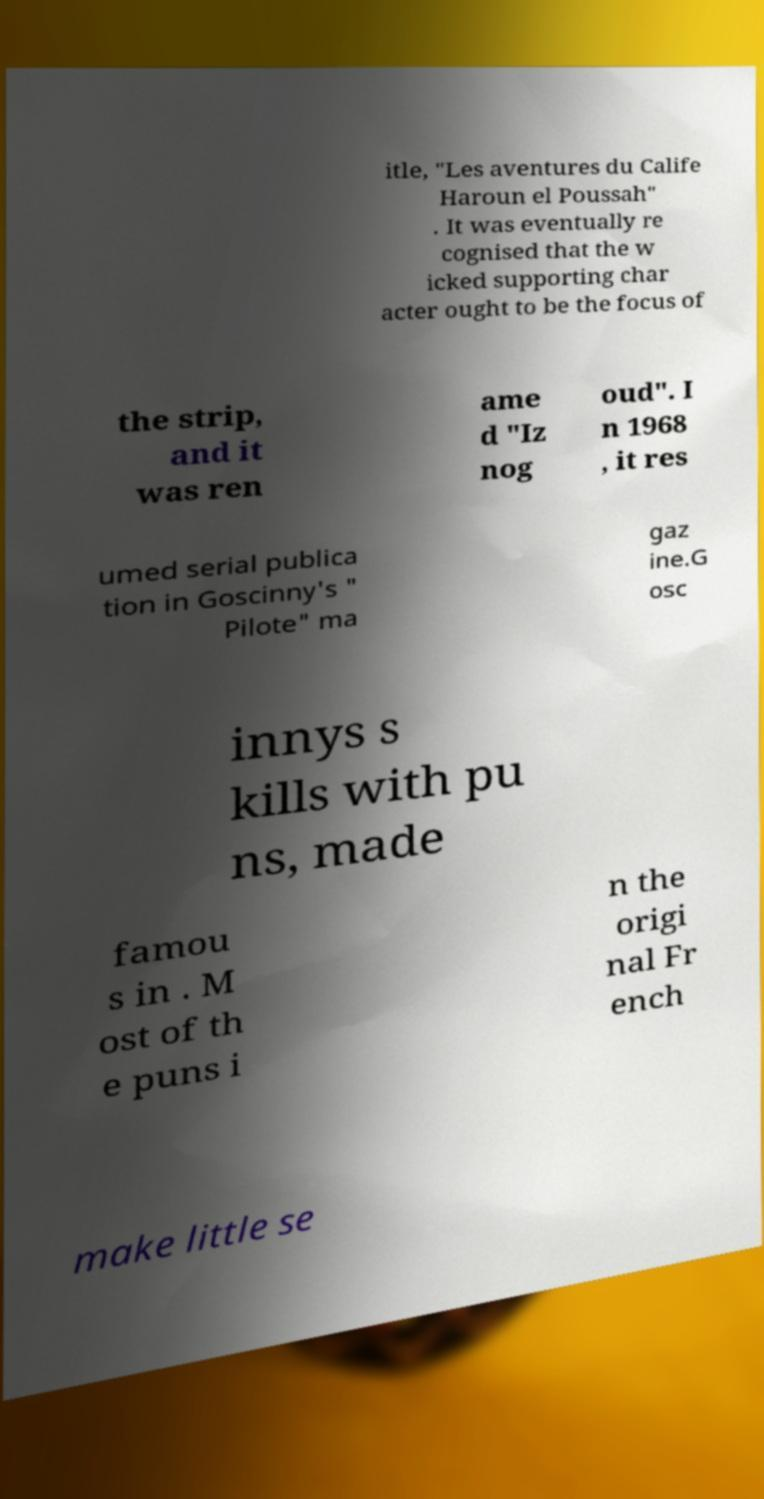There's text embedded in this image that I need extracted. Can you transcribe it verbatim? itle, "Les aventures du Calife Haroun el Poussah" . It was eventually re cognised that the w icked supporting char acter ought to be the focus of the strip, and it was ren ame d "Iz nog oud". I n 1968 , it res umed serial publica tion in Goscinny's " Pilote" ma gaz ine.G osc innys s kills with pu ns, made famou s in . M ost of th e puns i n the origi nal Fr ench make little se 